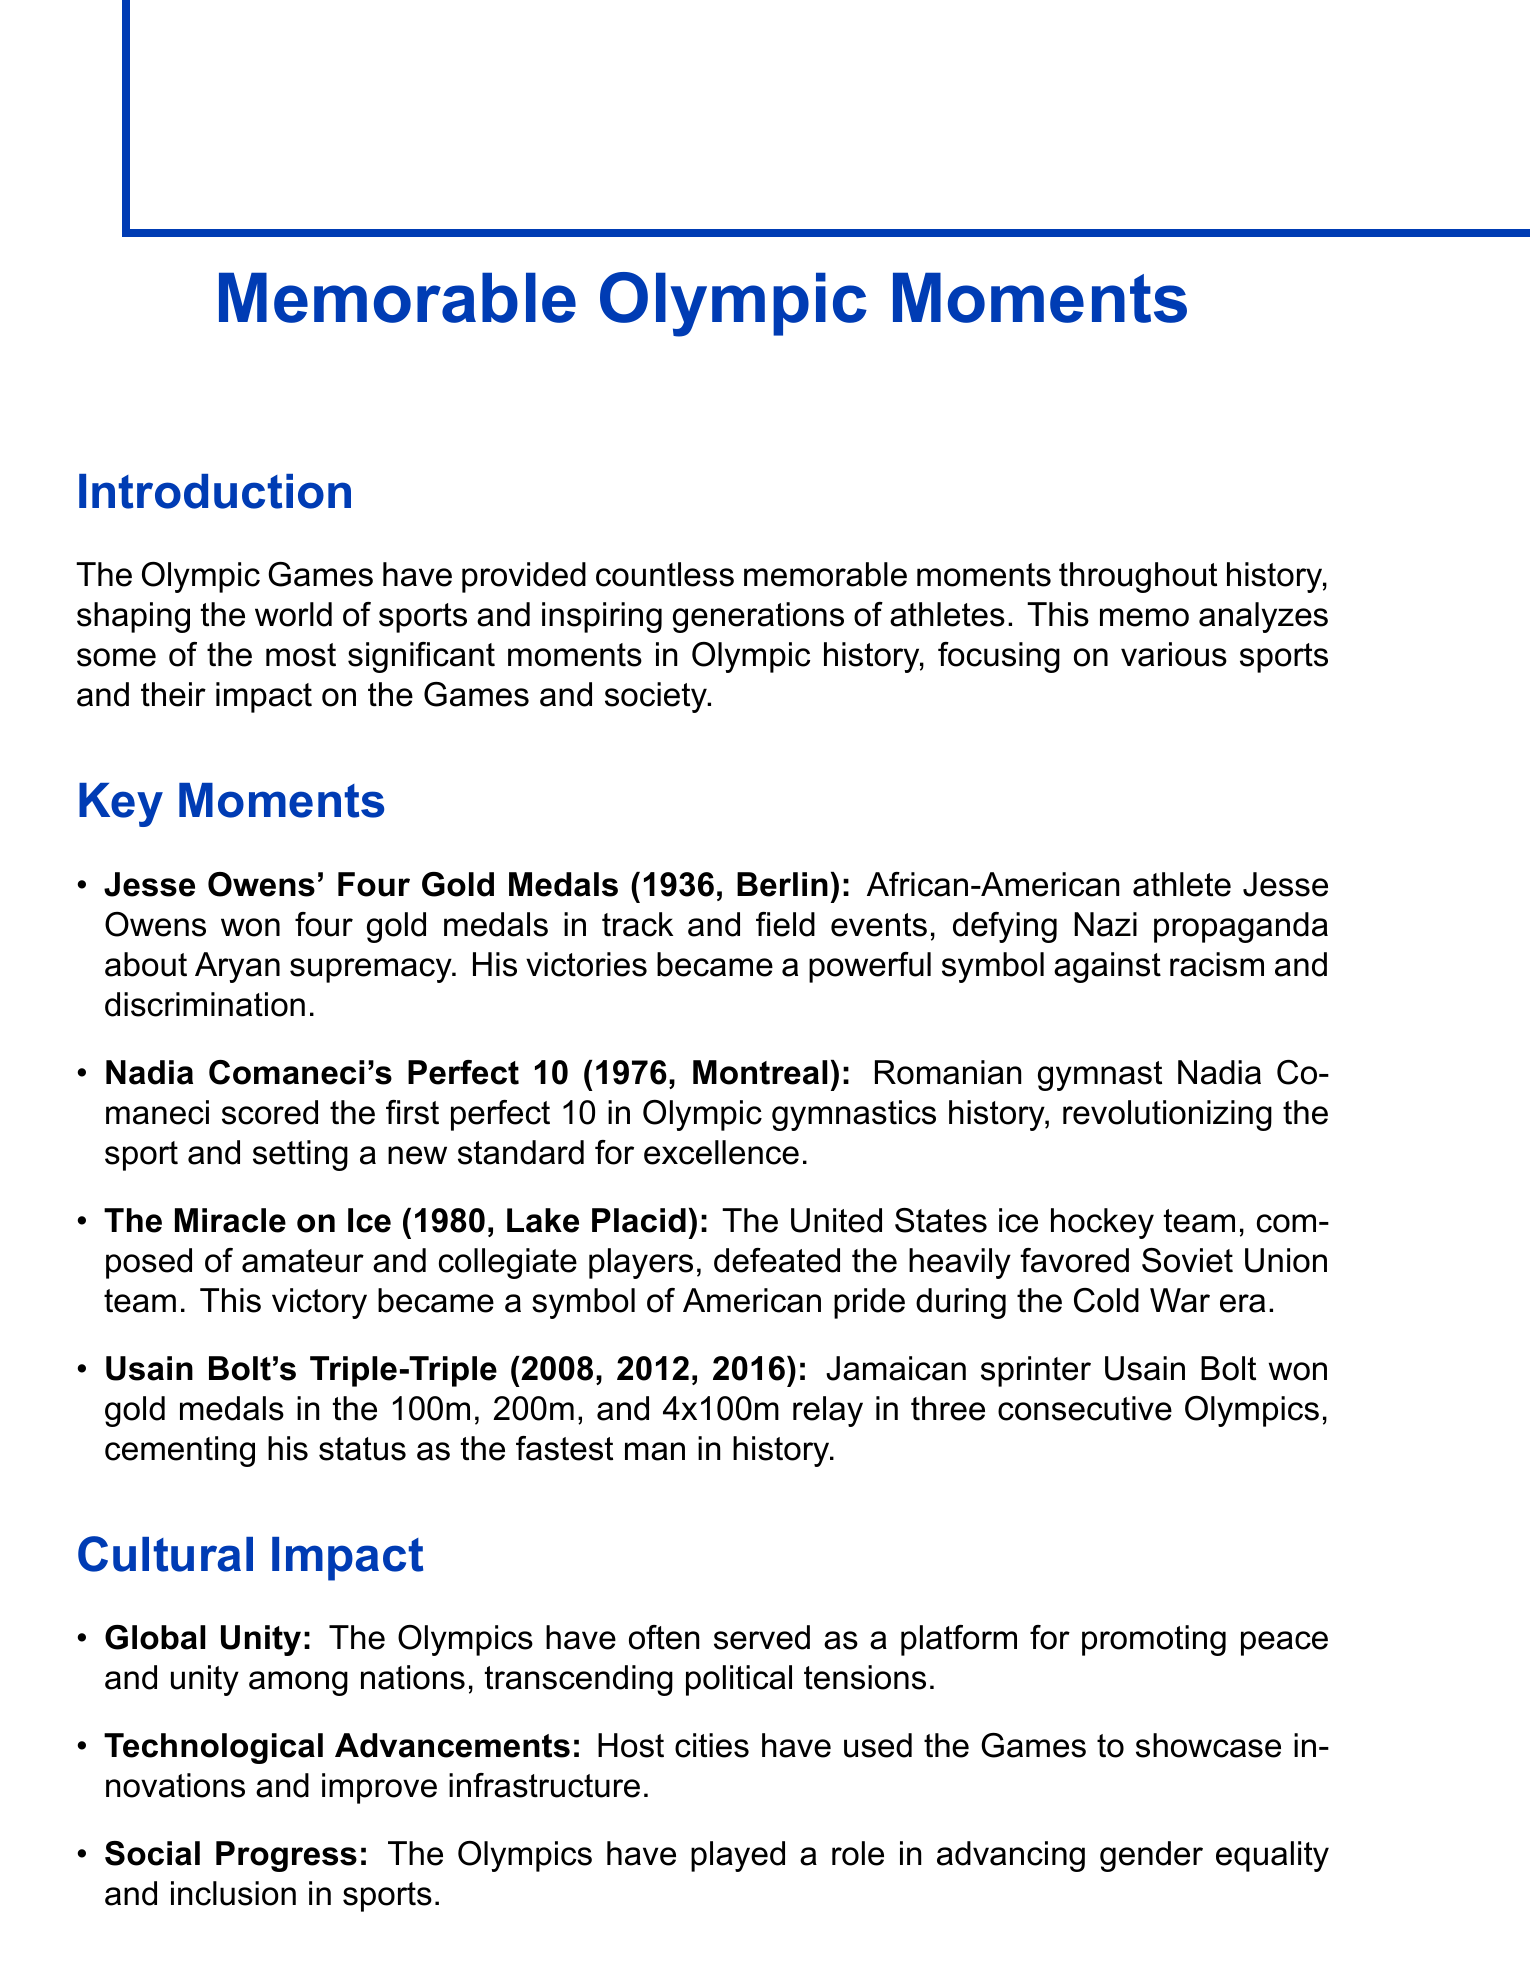What event did Jesse Owens participate in? Jesse Owens participated in track and field events during the Olympics.
Answer: track and field What year did Nadia Comaneci score the first perfect 10? The document specifies that Nadia Comaneci achieved this milestone in 1976.
Answer: 1976 Which Olympics is referred to as "The Miracle on Ice"? The document states that this event took place during the 1980 Olympics.
Answer: 1980 How many gold medals did Usain Bolt win in three consecutive Olympics? The memo indicates that Usain Bolt won a total of three gold medals at each of the three Olympics mentioned.
Answer: 9 What country hosted the 1976 Olympic Games? The memo mentions that the 1976 Olympics were held in Montreal, Canada.
Answer: Canada What significant event occurred during the 1972 Munich Olympics? The document describes a tragic event involving terrorists killing Israeli athletes.
Answer: Massacre What cultural impact do the Olympics promote among nations? The document highlights that the Olympics serve as a platform for promoting peace and unity.
Answer: peace and unity What was a significant consequence of the Cold War mentioned in the document? The document addresses that numerous countries boycotted the Moscow and Los Angeles Olympics due to Cold War tensions.
Answer: boycotts What is the main purpose of this memo? The purpose is to analyze significant moments in Olympic history and their societal impacts.
Answer: analyze significant moments 